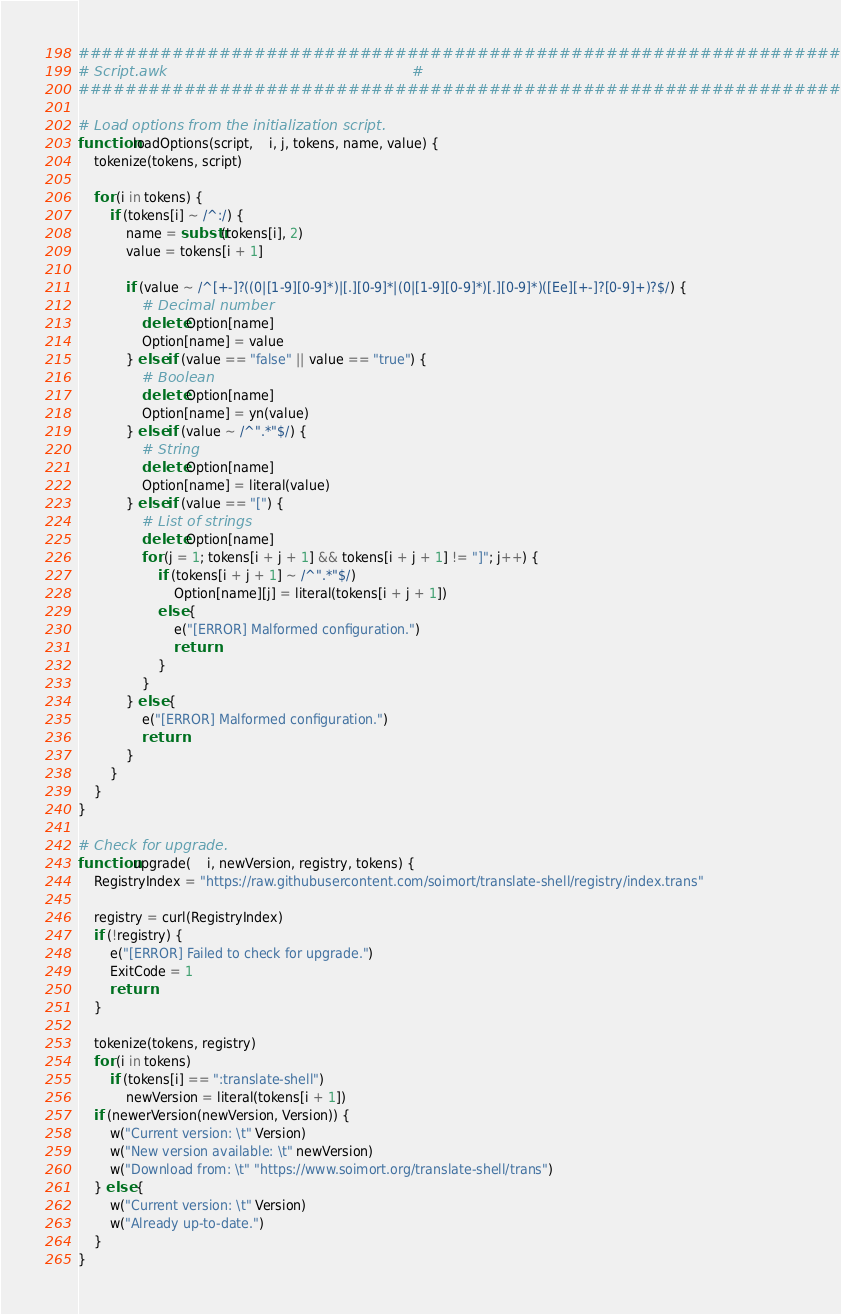Convert code to text. <code><loc_0><loc_0><loc_500><loc_500><_Awk_>####################################################################
# Script.awk                                                       #
####################################################################

# Load options from the initialization script.
function loadOptions(script,    i, j, tokens, name, value) {
    tokenize(tokens, script)

    for (i in tokens) {
        if (tokens[i] ~ /^:/) {
            name = substr(tokens[i], 2)
            value = tokens[i + 1]

            if (value ~ /^[+-]?((0|[1-9][0-9]*)|[.][0-9]*|(0|[1-9][0-9]*)[.][0-9]*)([Ee][+-]?[0-9]+)?$/) {
                # Decimal number
                delete Option[name]
                Option[name] = value
            } else if (value == "false" || value == "true") {
                # Boolean
                delete Option[name]
                Option[name] = yn(value)
            } else if (value ~ /^".*"$/) {
                # String
                delete Option[name]
                Option[name] = literal(value)
            } else if (value == "[") {
                # List of strings
                delete Option[name]
                for (j = 1; tokens[i + j + 1] && tokens[i + j + 1] != "]"; j++) {
                    if (tokens[i + j + 1] ~ /^".*"$/)
                        Option[name][j] = literal(tokens[i + j + 1])
                    else {
                        e("[ERROR] Malformed configuration.")
                        return
                    }
                }
            } else {
                e("[ERROR] Malformed configuration.")
                return
            }
        }
    }
}

# Check for upgrade.
function upgrade(    i, newVersion, registry, tokens) {
    RegistryIndex = "https://raw.githubusercontent.com/soimort/translate-shell/registry/index.trans"

    registry = curl(RegistryIndex)
    if (!registry) {
        e("[ERROR] Failed to check for upgrade.")
        ExitCode = 1
        return
    }

    tokenize(tokens, registry)
    for (i in tokens)
        if (tokens[i] == ":translate-shell")
            newVersion = literal(tokens[i + 1])
    if (newerVersion(newVersion, Version)) {
        w("Current version: \t" Version)
        w("New version available: \t" newVersion)
        w("Download from: \t" "https://www.soimort.org/translate-shell/trans")
    } else {
        w("Current version: \t" Version)
        w("Already up-to-date.")
    }
}
</code> 